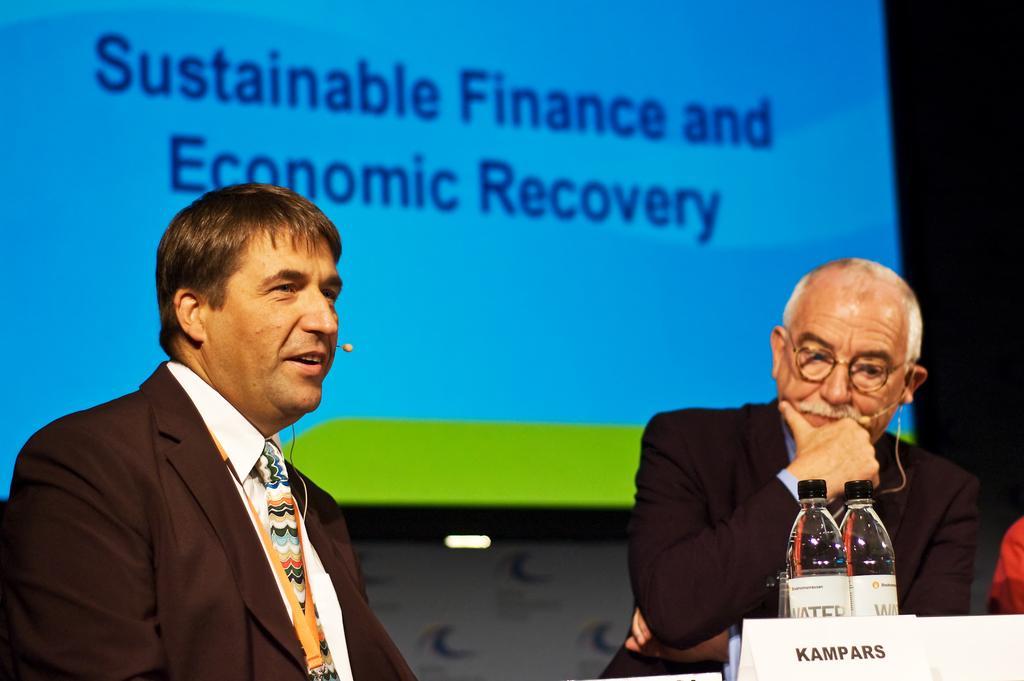Could you give a brief overview of what you see in this image? In this image we can see two persons there are water bottles and a name board in front of the person and there is a presentation screen in the background. 